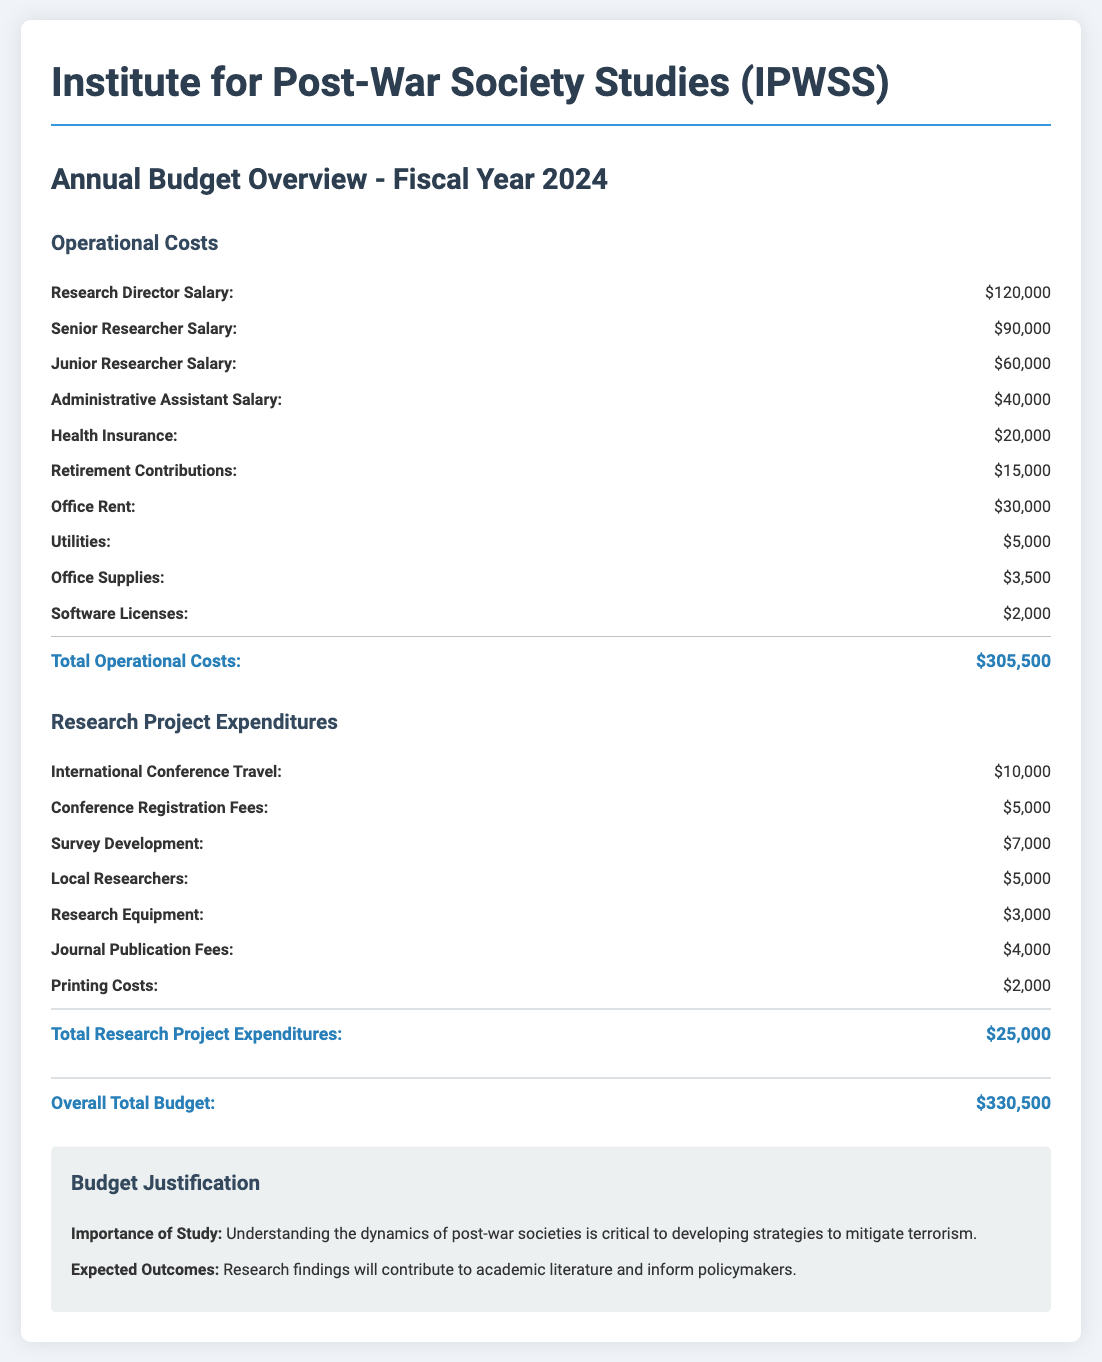What is the total amount allocated for operational costs? The total for operational costs is listed under that section, which is $305,500.
Answer: $305,500 How much is allocated for the Research Director's salary? The salary for the Research Director is shown separately under operational costs, which is $120,000.
Answer: $120,000 What are the total research project expenditures? The total research project expenditures are provided in that section as $25,000.
Answer: $25,000 What is the total budget for the fiscal year 2024? The overall total budget is found in the summary section at the bottom, which is $330,500.
Answer: $330,500 What is the amount set aside for health insurance? Health insurance costs are specified in the operational costs and total $20,000.
Answer: $20,000 What is the purpose of this budget overview? The importance of the budget is explained in the justification section that highlights understanding the dynamics of post-war societies.
Answer: Understanding the dynamics of post-war societies How much is budgeted for international conference travel? The budget for international conference travel is included in the research project expenditures as $10,000.
Answer: $10,000 What is the main expected outcome of the research? The main expected outcome is stated in the justification section, focusing on contributions to academic literature and informing policymakers.
Answer: Contributions to academic literature and informing policymakers What is the salary for a Junior Researcher? The salary for a Junior Researcher is indicated in the operational costs as $60,000.
Answer: $60,000 What item has the lowest expenditure in the operational costs? The operational costs show that office supplies have the lowest expenditure at $3,500.
Answer: $3,500 